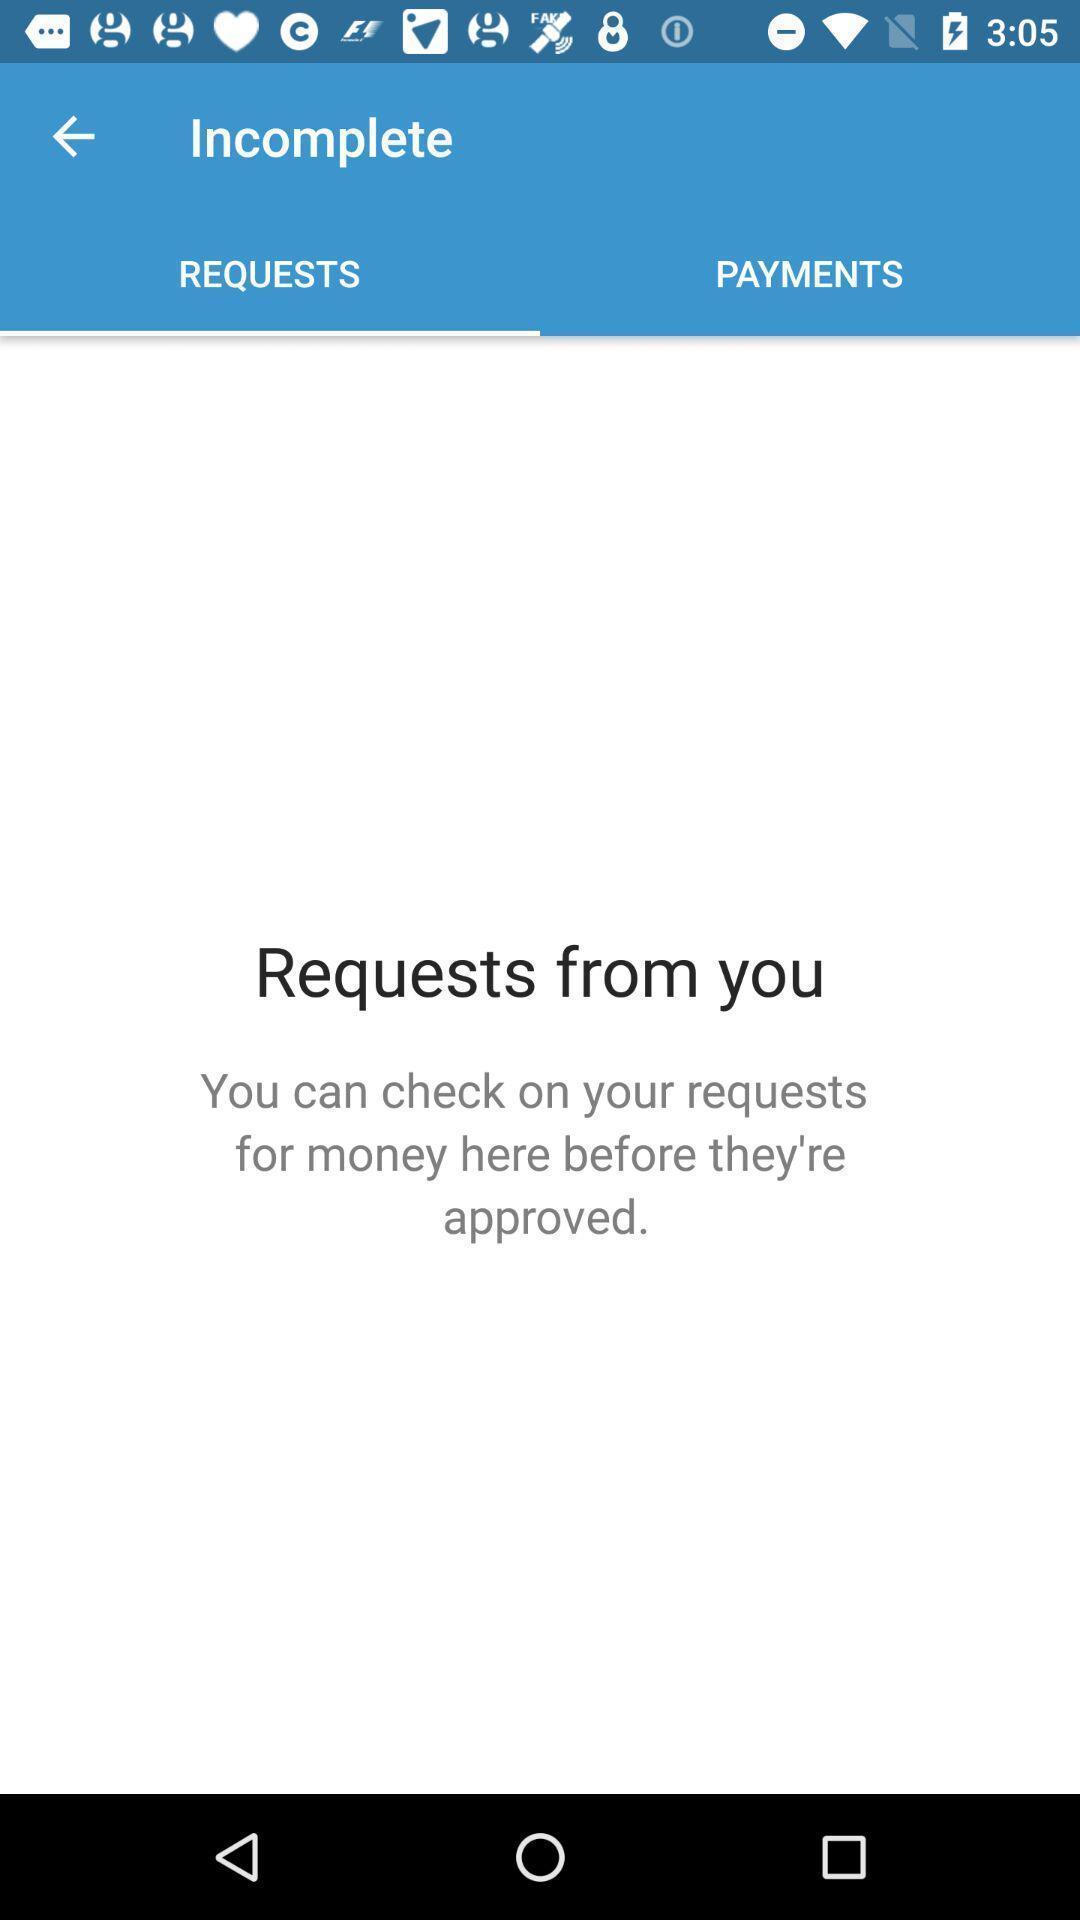Tell me about the visual elements in this screen capture. Page for checking requests for money of a financial app. 